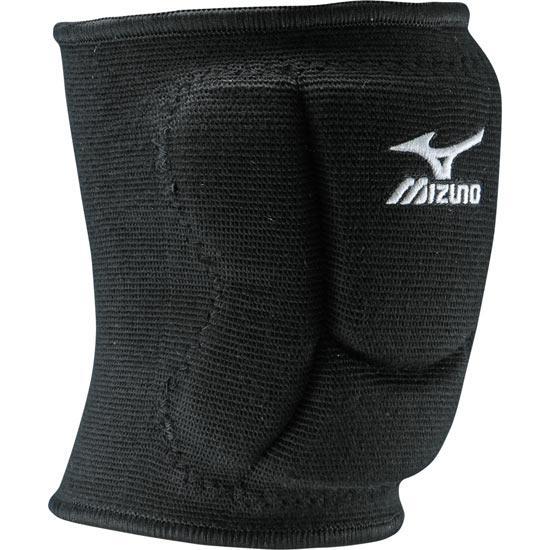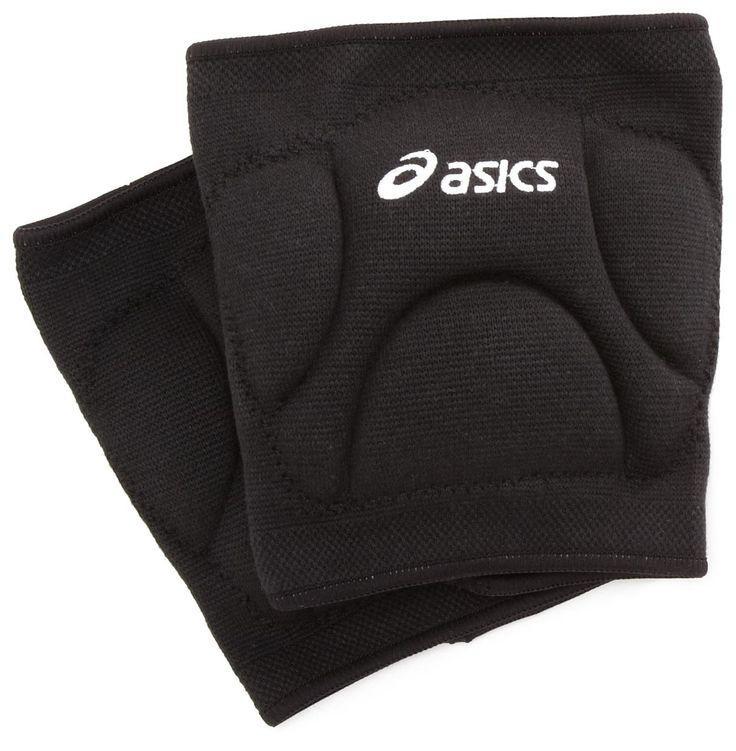The first image is the image on the left, the second image is the image on the right. Given the left and right images, does the statement "Each image shows a pair of black knee pads." hold true? Answer yes or no. No. The first image is the image on the left, the second image is the image on the right. Evaluate the accuracy of this statement regarding the images: "One of the pairs of pads is incomplete.". Is it true? Answer yes or no. Yes. 